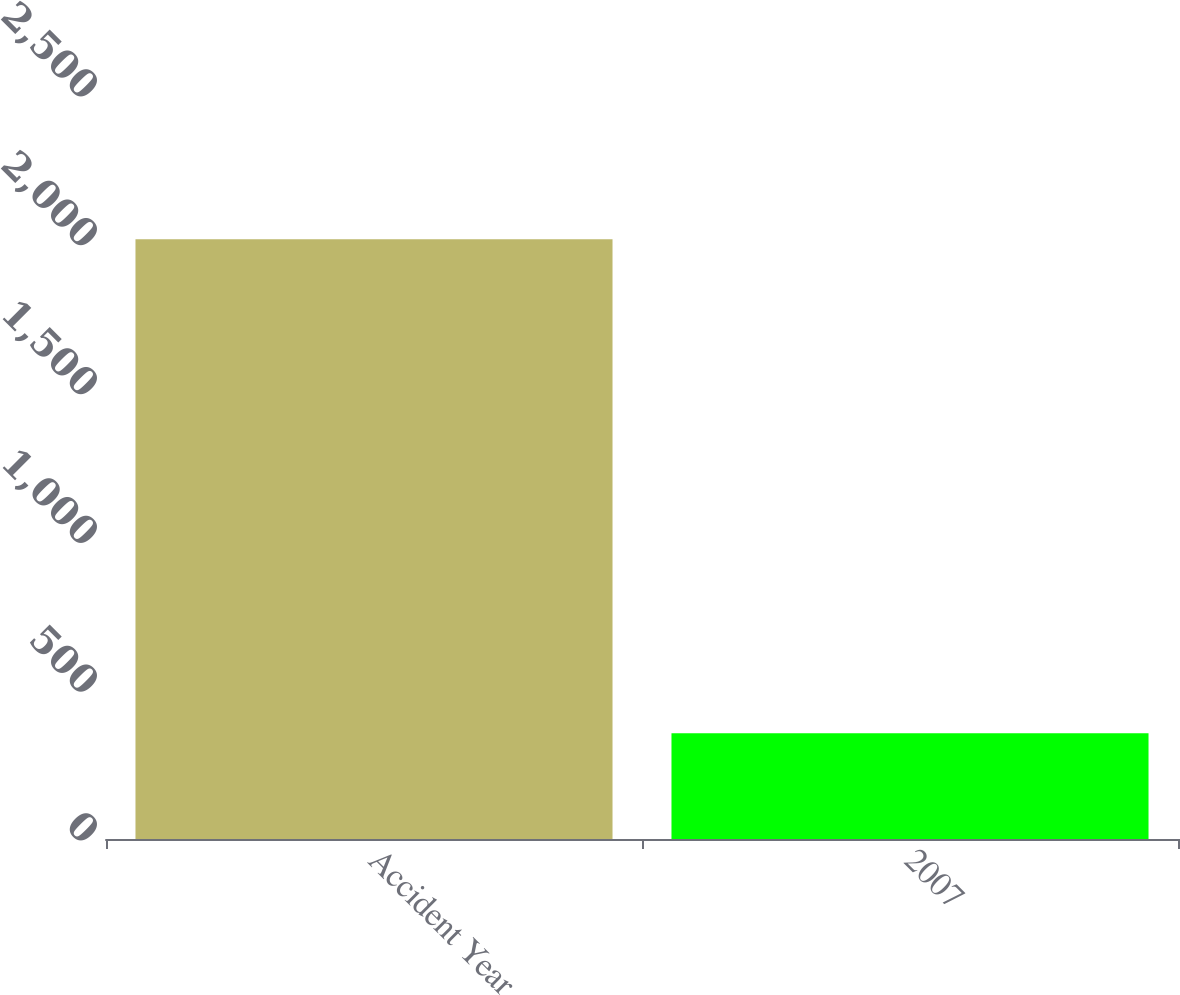Convert chart to OTSL. <chart><loc_0><loc_0><loc_500><loc_500><bar_chart><fcel>Accident Year<fcel>2007<nl><fcel>2015<fcel>355<nl></chart> 